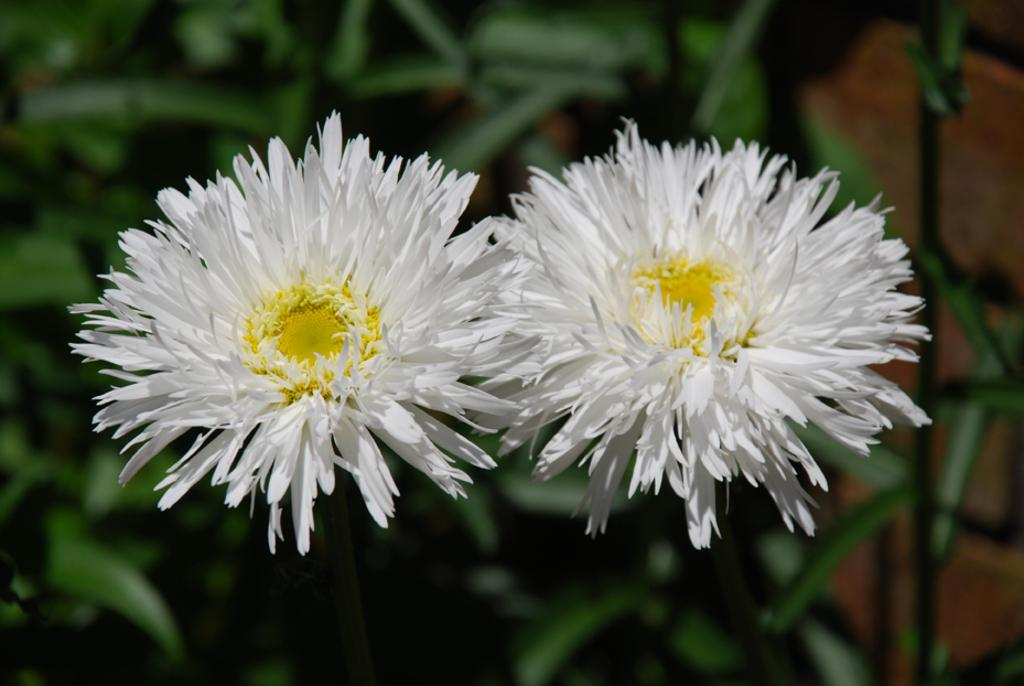What type of flowers are on the plant in the image? There are white flowers on the plant in the image. What can be seen at the bottom of the image? The ground is visible at the bottom of the image. What type of mountain is visible in the background of the image? There is no mountain visible in the background of the image. 